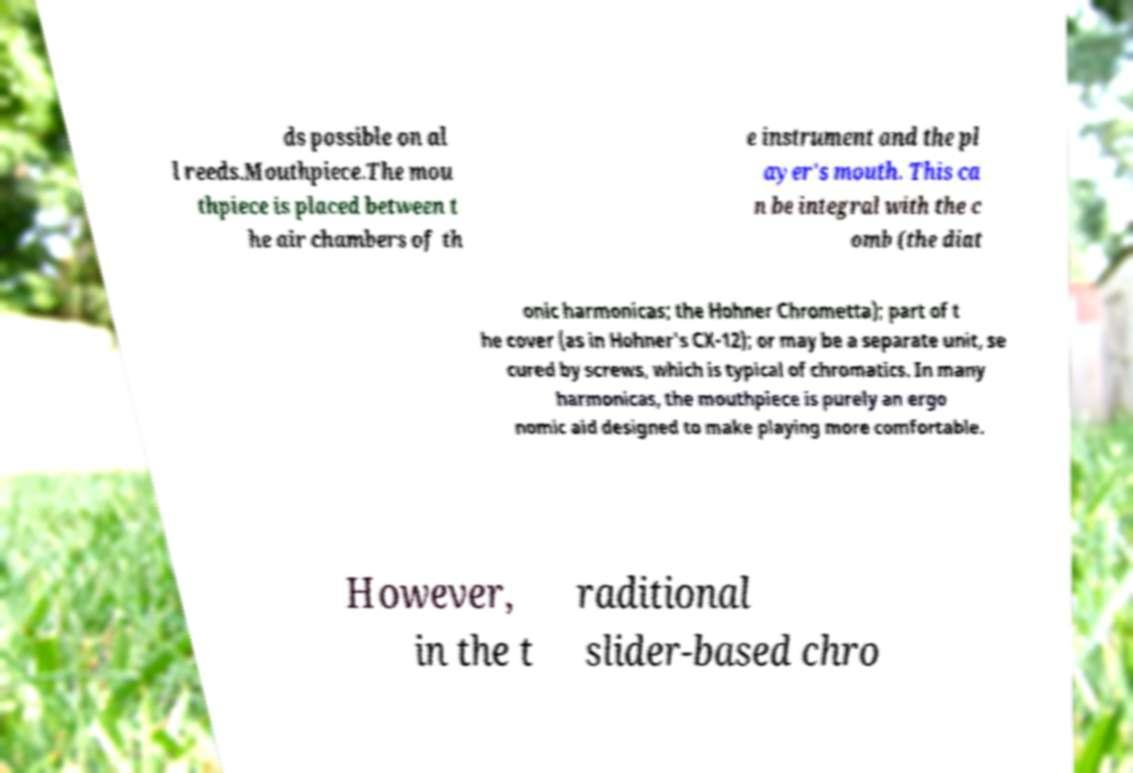Can you read and provide the text displayed in the image?This photo seems to have some interesting text. Can you extract and type it out for me? ds possible on al l reeds.Mouthpiece.The mou thpiece is placed between t he air chambers of th e instrument and the pl ayer's mouth. This ca n be integral with the c omb (the diat onic harmonicas; the Hohner Chrometta); part of t he cover (as in Hohner's CX-12); or may be a separate unit, se cured by screws, which is typical of chromatics. In many harmonicas, the mouthpiece is purely an ergo nomic aid designed to make playing more comfortable. However, in the t raditional slider-based chro 